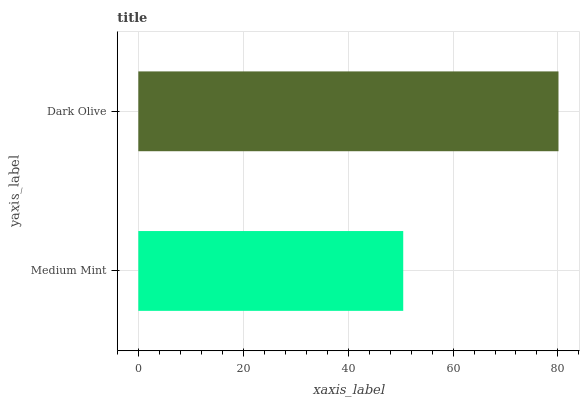Is Medium Mint the minimum?
Answer yes or no. Yes. Is Dark Olive the maximum?
Answer yes or no. Yes. Is Dark Olive the minimum?
Answer yes or no. No. Is Dark Olive greater than Medium Mint?
Answer yes or no. Yes. Is Medium Mint less than Dark Olive?
Answer yes or no. Yes. Is Medium Mint greater than Dark Olive?
Answer yes or no. No. Is Dark Olive less than Medium Mint?
Answer yes or no. No. Is Dark Olive the high median?
Answer yes or no. Yes. Is Medium Mint the low median?
Answer yes or no. Yes. Is Medium Mint the high median?
Answer yes or no. No. Is Dark Olive the low median?
Answer yes or no. No. 